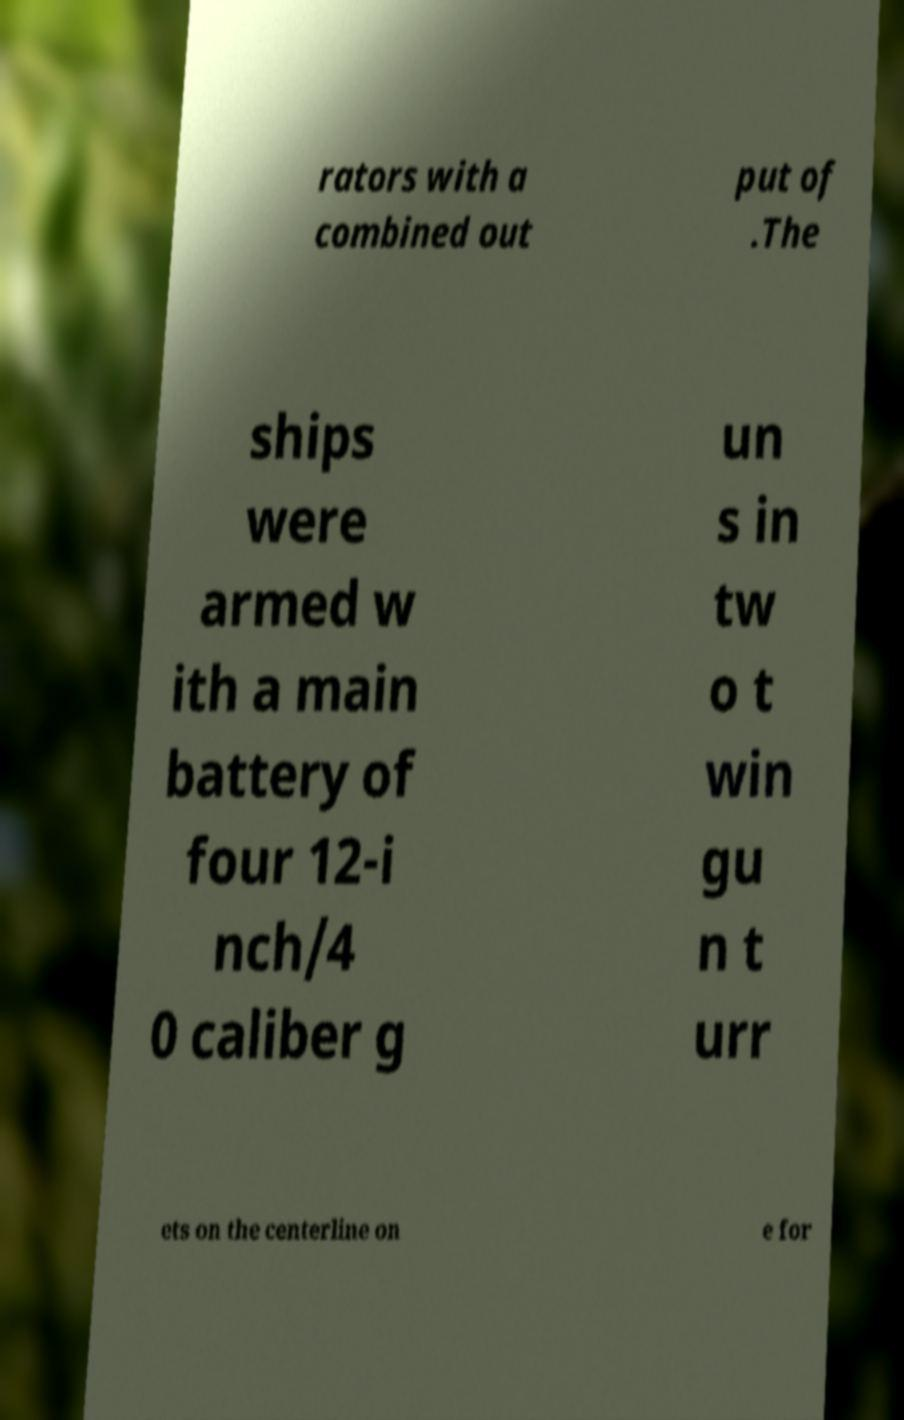There's text embedded in this image that I need extracted. Can you transcribe it verbatim? rators with a combined out put of .The ships were armed w ith a main battery of four 12-i nch/4 0 caliber g un s in tw o t win gu n t urr ets on the centerline on e for 